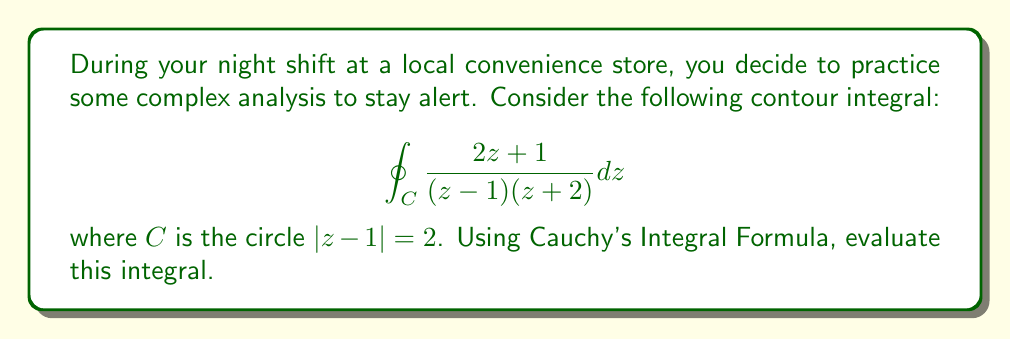What is the answer to this math problem? Let's approach this step-by-step:

1) First, we need to identify the poles inside the contour. The contour is a circle centered at $z=1$ with radius 2. The poles of the function are at $z=1$ and $z=-2$. Only $z=1$ is inside our contour.

2) We can rewrite our function in the form required by Cauchy's Integral Formula:

   $$\frac{2z+1}{(z-1)(z+2)} = \frac{A}{z-1} + \frac{B}{z+2}$$

   where $A$ and $B$ are constants we need to determine.

3) To find $A$, we multiply both sides by $(z-1)$ and then let $z$ approach 1:

   $$A = \lim_{z \to 1} \frac{(2z+1)}{(z+2)} = \frac{3}{3} = 1$$

4) Now that we have $A$, we can apply Cauchy's Integral Formula. The formula states:

   $$\oint_C \frac{f(z)}{z-a} dz = 2\pi i f(a)$$

   where $a$ is inside the contour $C$.

5) In our case, $a=1$ and $f(z) = 1$, so:

   $$\oint_C \frac{1}{z-1} dz = 2\pi i (1) = 2\pi i$$

6) Therefore, our final answer is $2\pi i$.
Answer: $2\pi i$ 